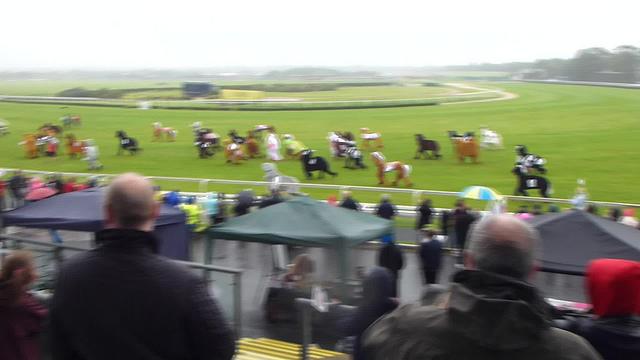How many tents are in the image?
Write a very short answer. 3. Are they watching a horse race?
Answer briefly. Yes. Is the image blurry?
Be succinct. Yes. How long have they been watching the game?
Keep it brief. 1 hour. 